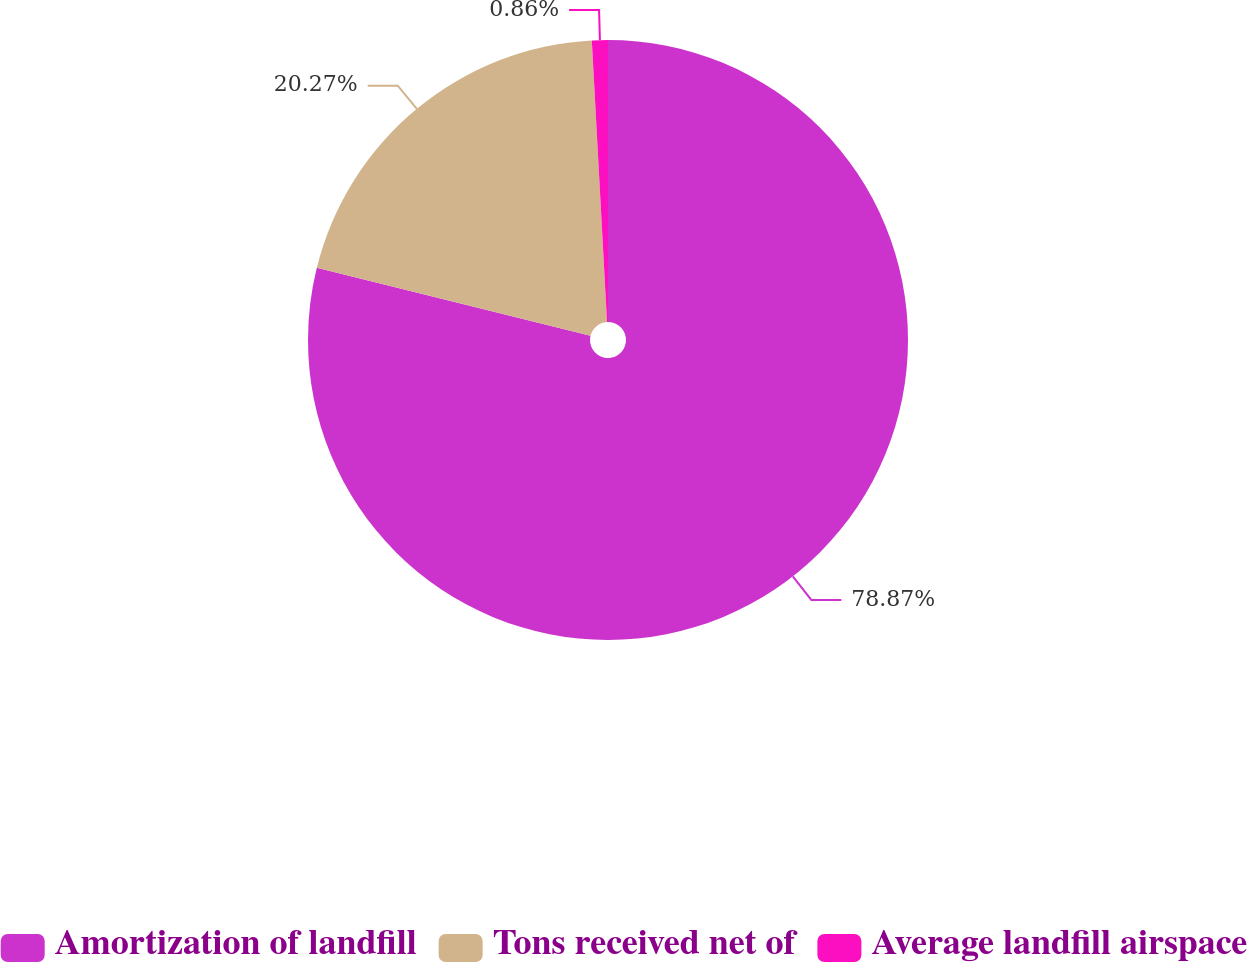<chart> <loc_0><loc_0><loc_500><loc_500><pie_chart><fcel>Amortization of landfill<fcel>Tons received net of<fcel>Average landfill airspace<nl><fcel>78.87%<fcel>20.27%<fcel>0.86%<nl></chart> 